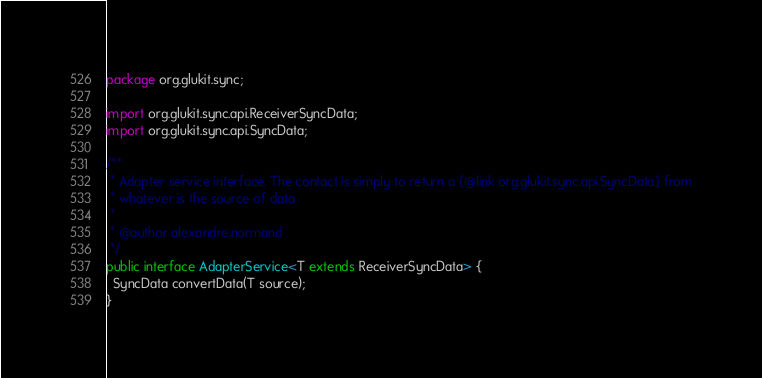<code> <loc_0><loc_0><loc_500><loc_500><_Java_>package org.glukit.sync;

import org.glukit.sync.api.ReceiverSyncData;
import org.glukit.sync.api.SyncData;

/**
 * Adapter service interface. The contact is simply to return a {@link org.glukit.sync.api.SyncData} from
 * whatever is the source of data.
 *
 * @author alexandre.normand
 */
public interface AdapterService<T extends ReceiverSyncData> {
  SyncData convertData(T source);
}
</code> 